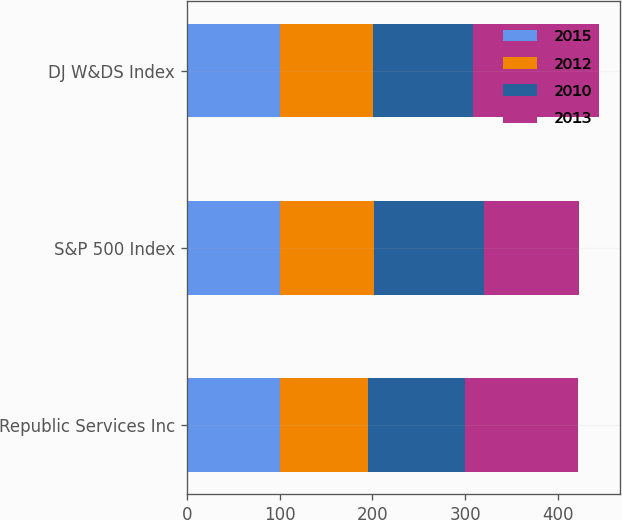Convert chart. <chart><loc_0><loc_0><loc_500><loc_500><stacked_bar_chart><ecel><fcel>Republic Services Inc<fcel>S&P 500 Index<fcel>DJ W&DS Index<nl><fcel>2015<fcel>100<fcel>100<fcel>100<nl><fcel>2012<fcel>94.96<fcel>102.11<fcel>100.18<nl><fcel>2010<fcel>104.47<fcel>118.45<fcel>108.7<nl><fcel>2013<fcel>121.84<fcel>102.11<fcel>135.8<nl></chart> 